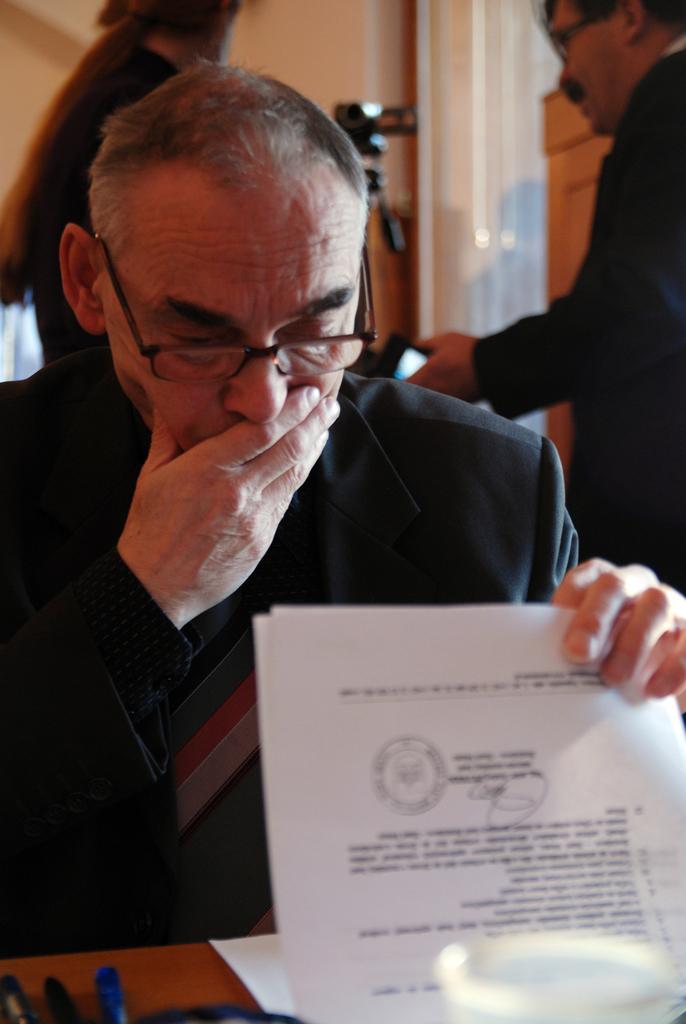Could you give a brief overview of what you see in this image? In this image I can see a person sitting wearing black color blazer and holding few papers, background I can see few persons standing, wall in cream color. 